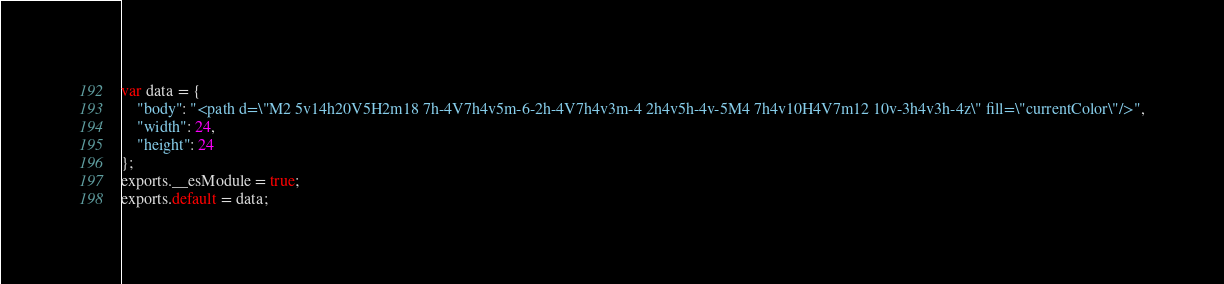Convert code to text. <code><loc_0><loc_0><loc_500><loc_500><_JavaScript_>var data = {
	"body": "<path d=\"M2 5v14h20V5H2m18 7h-4V7h4v5m-6-2h-4V7h4v3m-4 2h4v5h-4v-5M4 7h4v10H4V7m12 10v-3h4v3h-4z\" fill=\"currentColor\"/>",
	"width": 24,
	"height": 24
};
exports.__esModule = true;
exports.default = data;
</code> 